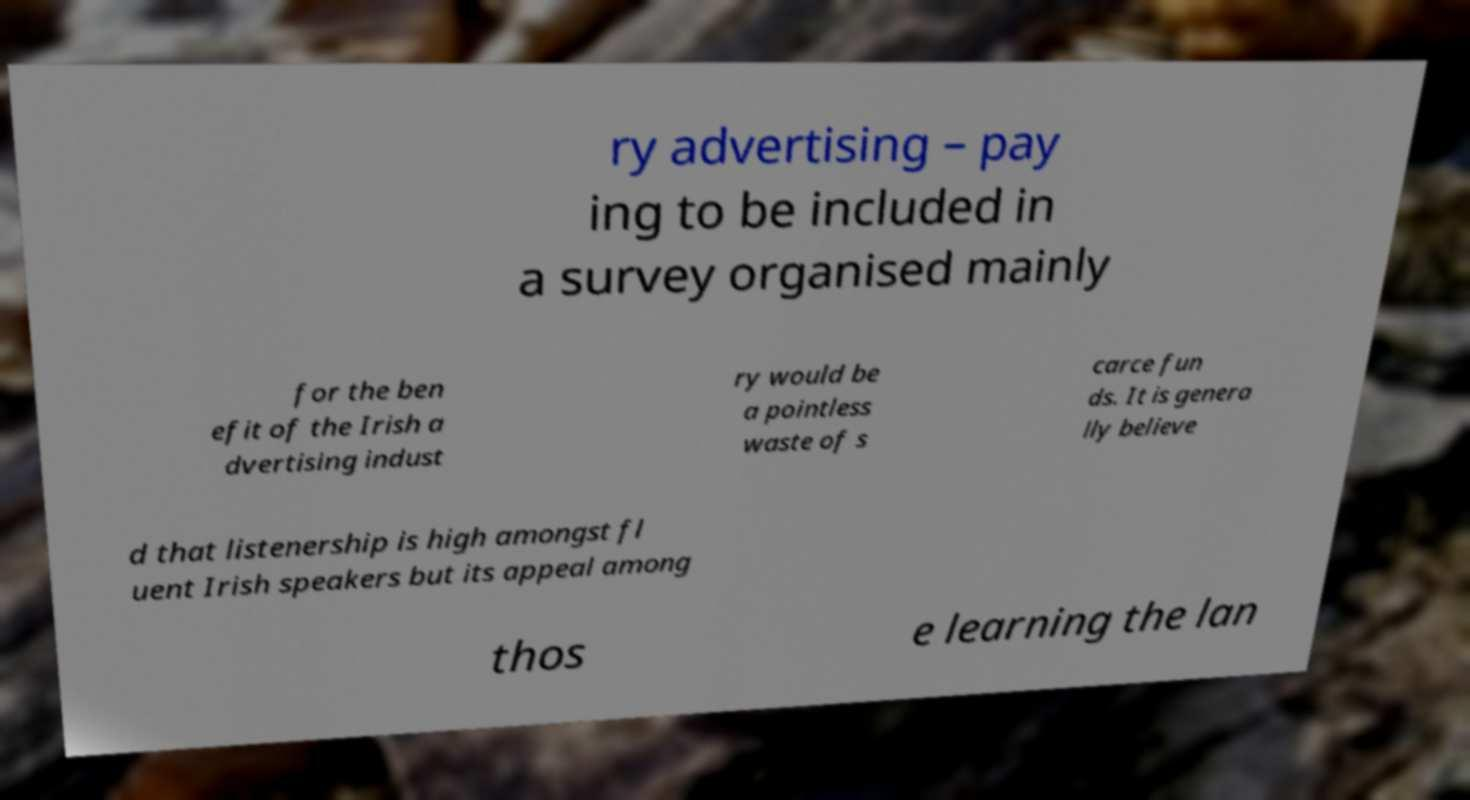I need the written content from this picture converted into text. Can you do that? ry advertising – pay ing to be included in a survey organised mainly for the ben efit of the Irish a dvertising indust ry would be a pointless waste of s carce fun ds. It is genera lly believe d that listenership is high amongst fl uent Irish speakers but its appeal among thos e learning the lan 